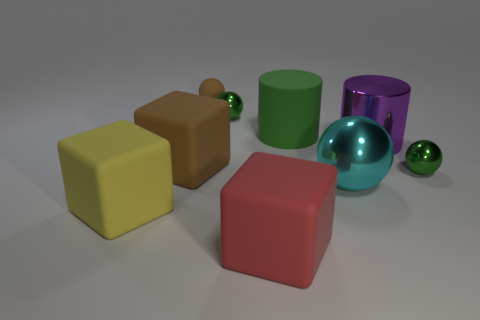What color is the cylinder that is made of the same material as the small brown object?
Ensure brevity in your answer.  Green. Are there fewer large green cylinders behind the rubber ball than rubber blocks?
Give a very brief answer. Yes. What is the shape of the other big thing that is the same material as the purple object?
Offer a terse response. Sphere. What number of metallic things are either small cyan things or small brown things?
Provide a succinct answer. 0. Are there the same number of small matte spheres left of the big brown block and red rubber cylinders?
Your answer should be compact. Yes. Do the shiny thing that is behind the large green object and the big rubber cylinder have the same color?
Provide a succinct answer. Yes. What is the ball that is on the left side of the large purple shiny cylinder and in front of the large brown matte thing made of?
Keep it short and to the point. Metal. Is there a small brown matte object that is left of the tiny metallic ball in front of the big brown object?
Keep it short and to the point. Yes. Is the material of the big green cylinder the same as the large yellow thing?
Provide a succinct answer. Yes. What is the shape of the rubber object that is on the right side of the brown rubber ball and behind the red object?
Provide a short and direct response. Cylinder. 